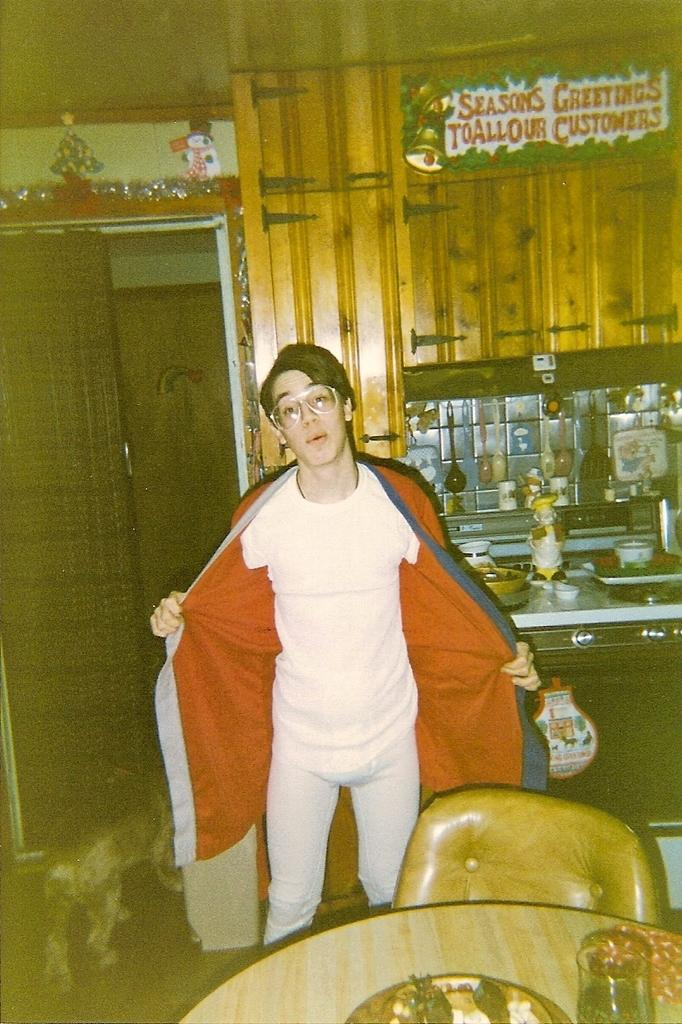Who is the main subject in the image? There is a boy in the image. What is the boy doing in the image? The boy is standing. What is the boy wearing in the image? The boy is wearing a white dress. What objects can be seen on the right side of the image? There is a table and a chair on the right side of the image. What type of holiday is the boy celebrating in the image? There is no indication of a holiday in the image. What is the size of the boy's teeth in the image? The image does not show the boy's teeth, so we cannot determine their size. 